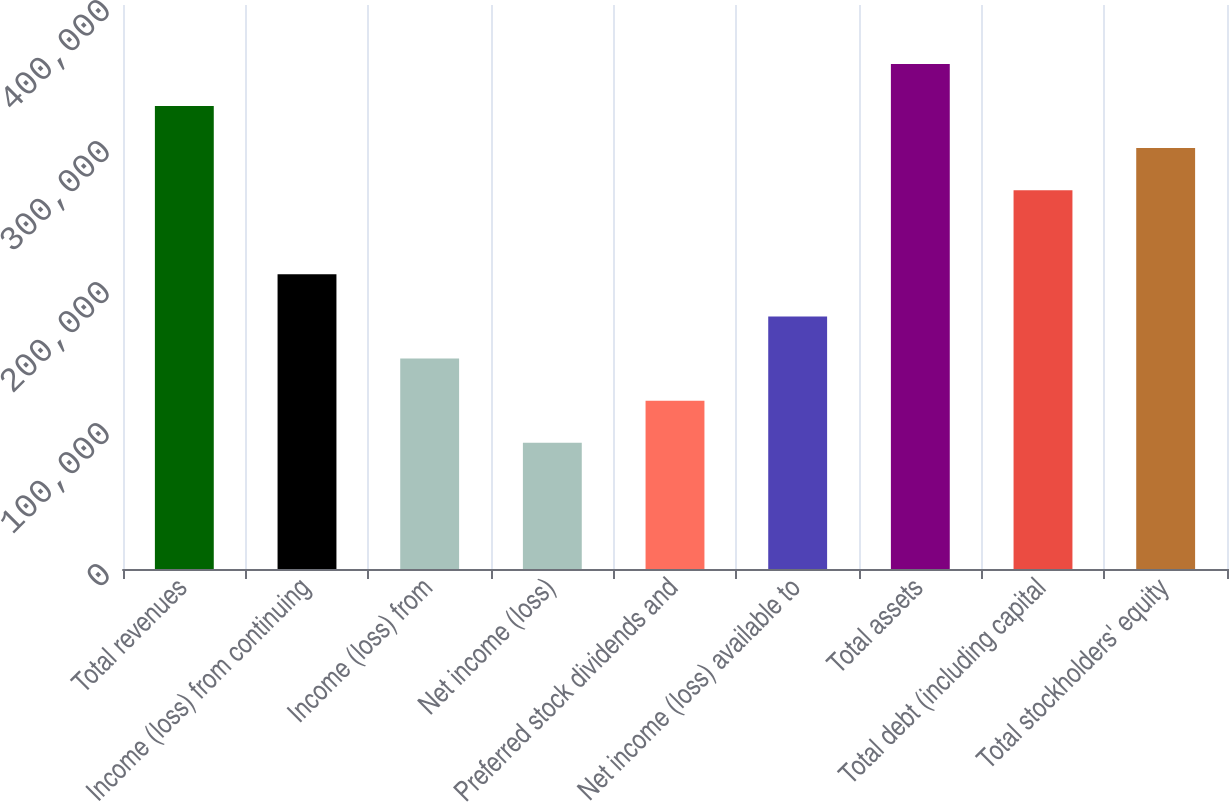Convert chart. <chart><loc_0><loc_0><loc_500><loc_500><bar_chart><fcel>Total revenues<fcel>Income (loss) from continuing<fcel>Income (loss) from<fcel>Net income (loss)<fcel>Preferred stock dividends and<fcel>Net income (loss) available to<fcel>Total assets<fcel>Total debt (including capital<fcel>Total stockholders' equity<nl><fcel>328364<fcel>208959<fcel>149257<fcel>89554<fcel>119405<fcel>179108<fcel>358216<fcel>268662<fcel>298513<nl></chart> 